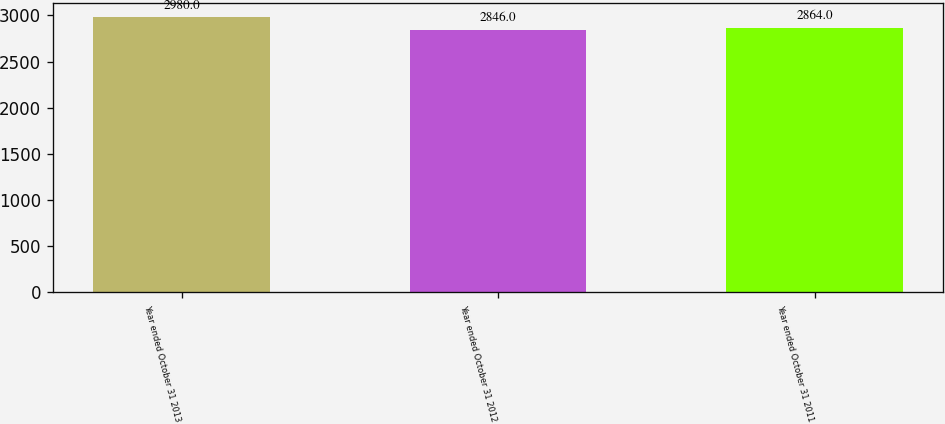Convert chart to OTSL. <chart><loc_0><loc_0><loc_500><loc_500><bar_chart><fcel>Year ended October 31 2013<fcel>Year ended October 31 2012<fcel>Year ended October 31 2011<nl><fcel>2980<fcel>2846<fcel>2864<nl></chart> 